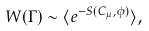Convert formula to latex. <formula><loc_0><loc_0><loc_500><loc_500>W ( \Gamma ) \sim \langle e ^ { - S ( C _ { \mu } , \phi ) } \rangle ,</formula> 